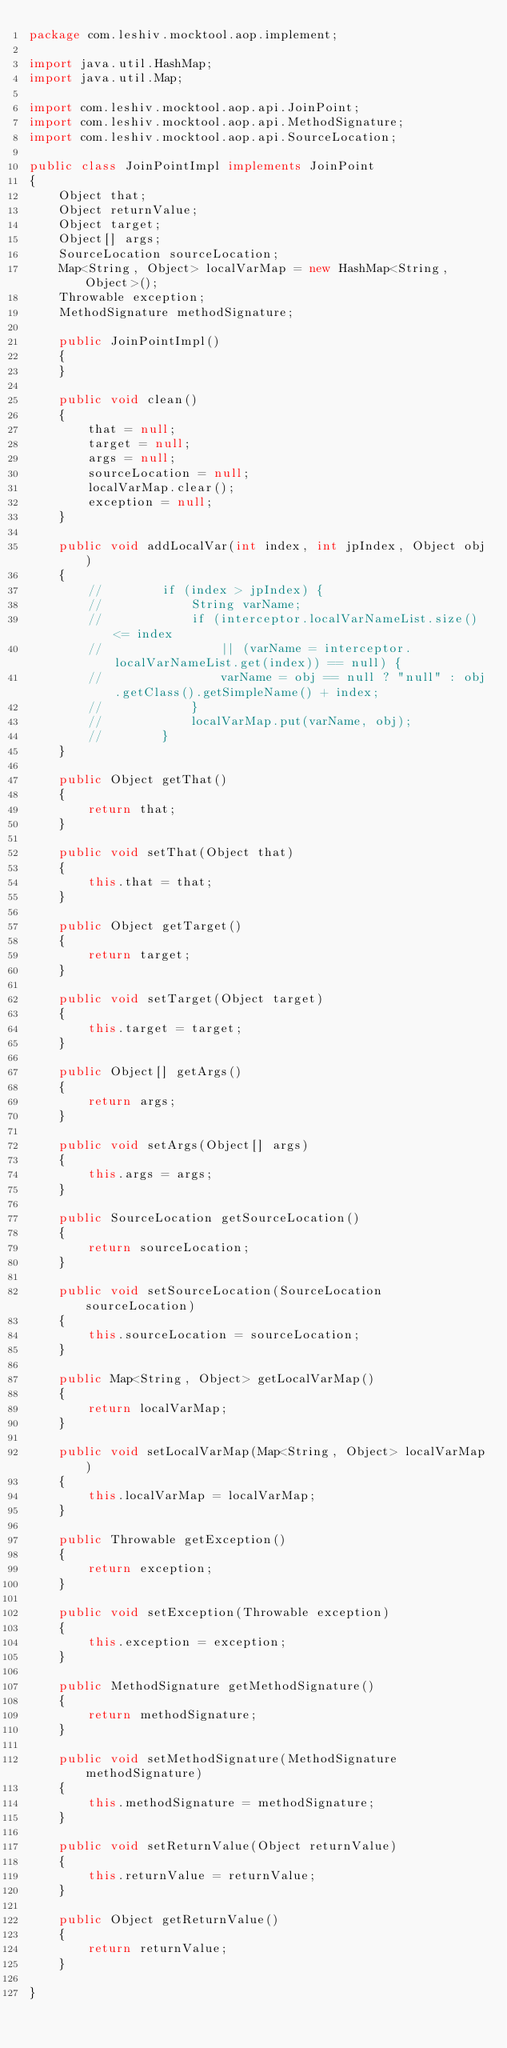Convert code to text. <code><loc_0><loc_0><loc_500><loc_500><_Java_>package com.leshiv.mocktool.aop.implement;

import java.util.HashMap;
import java.util.Map;

import com.leshiv.mocktool.aop.api.JoinPoint;
import com.leshiv.mocktool.aop.api.MethodSignature;
import com.leshiv.mocktool.aop.api.SourceLocation;

public class JoinPointImpl implements JoinPoint
{
	Object that;
	Object returnValue;
	Object target;
	Object[] args;
	SourceLocation sourceLocation;
	Map<String, Object> localVarMap = new HashMap<String, Object>();
	Throwable exception;
	MethodSignature methodSignature;

	public JoinPointImpl()
	{
	}

	public void clean()
	{
		that = null;
		target = null;
		args = null;
		sourceLocation = null;
		localVarMap.clear();
		exception = null;
	}

	public void addLocalVar(int index, int jpIndex, Object obj)
	{
		//        if (index > jpIndex) {
		//            String varName;
		//            if (interceptor.localVarNameList.size() <= index
		//                || (varName = interceptor.localVarNameList.get(index)) == null) {
		//                varName = obj == null ? "null" : obj.getClass().getSimpleName() + index;
		//            }
		//            localVarMap.put(varName, obj);
		//        }
	}

	public Object getThat()
	{
		return that;
	}

	public void setThat(Object that)
	{
		this.that = that;
	}

	public Object getTarget()
	{
		return target;
	}

	public void setTarget(Object target)
	{
		this.target = target;
	}

	public Object[] getArgs()
	{
		return args;
	}

	public void setArgs(Object[] args)
	{
		this.args = args;
	}

	public SourceLocation getSourceLocation()
	{
		return sourceLocation;
	}

	public void setSourceLocation(SourceLocation sourceLocation)
	{
		this.sourceLocation = sourceLocation;
	}

	public Map<String, Object> getLocalVarMap()
	{
		return localVarMap;
	}

	public void setLocalVarMap(Map<String, Object> localVarMap)
	{
		this.localVarMap = localVarMap;
	}

	public Throwable getException()
	{
		return exception;
	}

	public void setException(Throwable exception)
	{
		this.exception = exception;
	}

	public MethodSignature getMethodSignature()
	{
		return methodSignature;
	}

	public void setMethodSignature(MethodSignature methodSignature)
	{
		this.methodSignature = methodSignature;
	}

	public void setReturnValue(Object returnValue)
	{
		this.returnValue = returnValue;
	}

	public Object getReturnValue()
	{
		return returnValue;
	}

}
</code> 